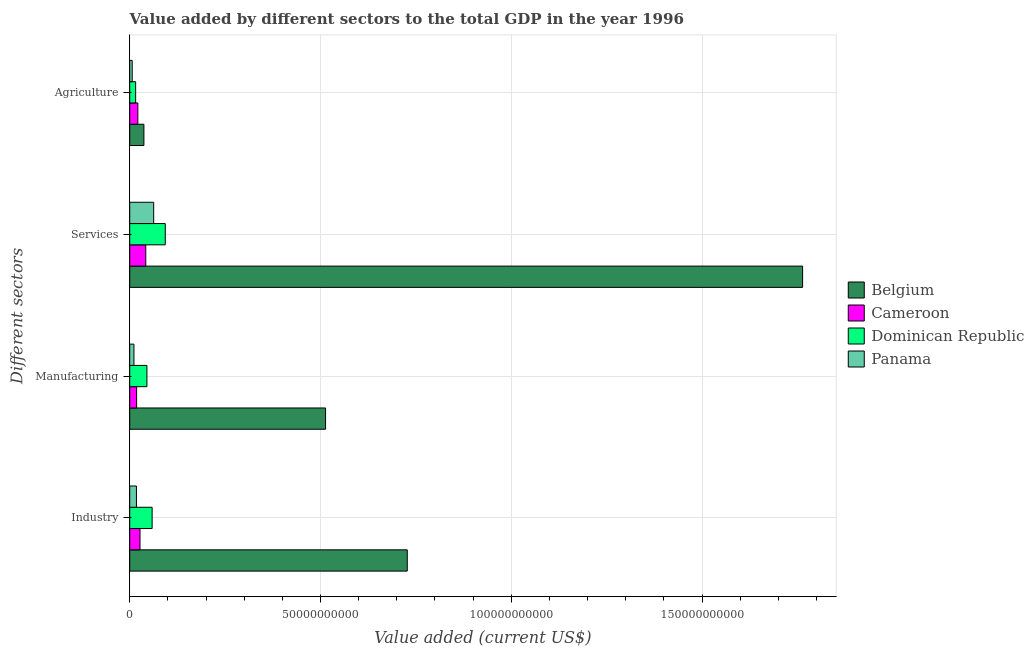How many different coloured bars are there?
Your response must be concise. 4. Are the number of bars on each tick of the Y-axis equal?
Offer a very short reply. Yes. How many bars are there on the 2nd tick from the bottom?
Offer a terse response. 4. What is the label of the 4th group of bars from the top?
Give a very brief answer. Industry. What is the value added by industrial sector in Cameroon?
Your answer should be compact. 2.69e+09. Across all countries, what is the maximum value added by manufacturing sector?
Your answer should be compact. 5.13e+1. Across all countries, what is the minimum value added by industrial sector?
Provide a short and direct response. 1.76e+09. In which country was the value added by industrial sector maximum?
Provide a succinct answer. Belgium. In which country was the value added by agricultural sector minimum?
Your answer should be very brief. Panama. What is the total value added by industrial sector in the graph?
Provide a short and direct response. 8.31e+1. What is the difference between the value added by manufacturing sector in Cameroon and that in Belgium?
Make the answer very short. -4.95e+1. What is the difference between the value added by industrial sector in Dominican Republic and the value added by manufacturing sector in Belgium?
Keep it short and to the point. -4.55e+1. What is the average value added by agricultural sector per country?
Make the answer very short. 2.01e+09. What is the difference between the value added by agricultural sector and value added by manufacturing sector in Cameroon?
Provide a succinct answer. 3.18e+08. In how many countries, is the value added by agricultural sector greater than 100000000000 US$?
Offer a very short reply. 0. What is the ratio of the value added by services sector in Dominican Republic to that in Panama?
Your answer should be very brief. 1.48. Is the difference between the value added by industrial sector in Belgium and Cameroon greater than the difference between the value added by services sector in Belgium and Cameroon?
Ensure brevity in your answer.  No. What is the difference between the highest and the second highest value added by agricultural sector?
Your response must be concise. 1.59e+09. What is the difference between the highest and the lowest value added by agricultural sector?
Your response must be concise. 3.07e+09. Is it the case that in every country, the sum of the value added by industrial sector and value added by agricultural sector is greater than the sum of value added by manufacturing sector and value added by services sector?
Offer a very short reply. No. What does the 1st bar from the top in Agriculture represents?
Your answer should be very brief. Panama. What does the 4th bar from the bottom in Manufacturing represents?
Keep it short and to the point. Panama. Is it the case that in every country, the sum of the value added by industrial sector and value added by manufacturing sector is greater than the value added by services sector?
Keep it short and to the point. No. Does the graph contain any zero values?
Your answer should be compact. No. Does the graph contain grids?
Your response must be concise. Yes. Where does the legend appear in the graph?
Provide a short and direct response. Center right. How many legend labels are there?
Offer a very short reply. 4. How are the legend labels stacked?
Keep it short and to the point. Vertical. What is the title of the graph?
Keep it short and to the point. Value added by different sectors to the total GDP in the year 1996. Does "Lebanon" appear as one of the legend labels in the graph?
Ensure brevity in your answer.  No. What is the label or title of the X-axis?
Your response must be concise. Value added (current US$). What is the label or title of the Y-axis?
Ensure brevity in your answer.  Different sectors. What is the Value added (current US$) of Belgium in Industry?
Offer a very short reply. 7.27e+1. What is the Value added (current US$) of Cameroon in Industry?
Keep it short and to the point. 2.69e+09. What is the Value added (current US$) of Dominican Republic in Industry?
Ensure brevity in your answer.  5.87e+09. What is the Value added (current US$) of Panama in Industry?
Your answer should be compact. 1.76e+09. What is the Value added (current US$) of Belgium in Manufacturing?
Provide a short and direct response. 5.13e+1. What is the Value added (current US$) of Cameroon in Manufacturing?
Make the answer very short. 1.81e+09. What is the Value added (current US$) in Dominican Republic in Manufacturing?
Give a very brief answer. 4.51e+09. What is the Value added (current US$) of Panama in Manufacturing?
Ensure brevity in your answer.  1.11e+09. What is the Value added (current US$) in Belgium in Services?
Provide a short and direct response. 1.76e+11. What is the Value added (current US$) in Cameroon in Services?
Your answer should be very brief. 4.20e+09. What is the Value added (current US$) in Dominican Republic in Services?
Your response must be concise. 9.31e+09. What is the Value added (current US$) in Panama in Services?
Provide a short and direct response. 6.28e+09. What is the Value added (current US$) of Belgium in Agriculture?
Provide a short and direct response. 3.72e+09. What is the Value added (current US$) of Cameroon in Agriculture?
Give a very brief answer. 2.13e+09. What is the Value added (current US$) of Dominican Republic in Agriculture?
Make the answer very short. 1.55e+09. What is the Value added (current US$) of Panama in Agriculture?
Your response must be concise. 6.49e+08. Across all Different sectors, what is the maximum Value added (current US$) of Belgium?
Make the answer very short. 1.76e+11. Across all Different sectors, what is the maximum Value added (current US$) of Cameroon?
Keep it short and to the point. 4.20e+09. Across all Different sectors, what is the maximum Value added (current US$) of Dominican Republic?
Your answer should be compact. 9.31e+09. Across all Different sectors, what is the maximum Value added (current US$) of Panama?
Your answer should be very brief. 6.28e+09. Across all Different sectors, what is the minimum Value added (current US$) in Belgium?
Provide a succinct answer. 3.72e+09. Across all Different sectors, what is the minimum Value added (current US$) of Cameroon?
Provide a short and direct response. 1.81e+09. Across all Different sectors, what is the minimum Value added (current US$) of Dominican Republic?
Ensure brevity in your answer.  1.55e+09. Across all Different sectors, what is the minimum Value added (current US$) in Panama?
Keep it short and to the point. 6.49e+08. What is the total Value added (current US$) of Belgium in the graph?
Your response must be concise. 3.04e+11. What is the total Value added (current US$) of Cameroon in the graph?
Make the answer very short. 1.08e+1. What is the total Value added (current US$) of Dominican Republic in the graph?
Make the answer very short. 2.12e+1. What is the total Value added (current US$) in Panama in the graph?
Your response must be concise. 9.79e+09. What is the difference between the Value added (current US$) in Belgium in Industry and that in Manufacturing?
Your answer should be compact. 2.14e+1. What is the difference between the Value added (current US$) of Cameroon in Industry and that in Manufacturing?
Give a very brief answer. 8.81e+08. What is the difference between the Value added (current US$) of Dominican Republic in Industry and that in Manufacturing?
Ensure brevity in your answer.  1.37e+09. What is the difference between the Value added (current US$) of Panama in Industry and that in Manufacturing?
Keep it short and to the point. 6.53e+08. What is the difference between the Value added (current US$) of Belgium in Industry and that in Services?
Provide a short and direct response. -1.04e+11. What is the difference between the Value added (current US$) of Cameroon in Industry and that in Services?
Your answer should be very brief. -1.51e+09. What is the difference between the Value added (current US$) in Dominican Republic in Industry and that in Services?
Provide a succinct answer. -3.44e+09. What is the difference between the Value added (current US$) of Panama in Industry and that in Services?
Offer a terse response. -4.52e+09. What is the difference between the Value added (current US$) of Belgium in Industry and that in Agriculture?
Keep it short and to the point. 6.90e+1. What is the difference between the Value added (current US$) of Cameroon in Industry and that in Agriculture?
Offer a terse response. 5.63e+08. What is the difference between the Value added (current US$) in Dominican Republic in Industry and that in Agriculture?
Keep it short and to the point. 4.32e+09. What is the difference between the Value added (current US$) of Panama in Industry and that in Agriculture?
Keep it short and to the point. 1.11e+09. What is the difference between the Value added (current US$) in Belgium in Manufacturing and that in Services?
Provide a succinct answer. -1.25e+11. What is the difference between the Value added (current US$) in Cameroon in Manufacturing and that in Services?
Your response must be concise. -2.39e+09. What is the difference between the Value added (current US$) of Dominican Republic in Manufacturing and that in Services?
Ensure brevity in your answer.  -4.81e+09. What is the difference between the Value added (current US$) of Panama in Manufacturing and that in Services?
Your answer should be compact. -5.17e+09. What is the difference between the Value added (current US$) of Belgium in Manufacturing and that in Agriculture?
Your response must be concise. 4.76e+1. What is the difference between the Value added (current US$) of Cameroon in Manufacturing and that in Agriculture?
Ensure brevity in your answer.  -3.18e+08. What is the difference between the Value added (current US$) in Dominican Republic in Manufacturing and that in Agriculture?
Provide a succinct answer. 2.96e+09. What is the difference between the Value added (current US$) of Panama in Manufacturing and that in Agriculture?
Give a very brief answer. 4.57e+08. What is the difference between the Value added (current US$) of Belgium in Services and that in Agriculture?
Offer a terse response. 1.73e+11. What is the difference between the Value added (current US$) in Cameroon in Services and that in Agriculture?
Ensure brevity in your answer.  2.08e+09. What is the difference between the Value added (current US$) in Dominican Republic in Services and that in Agriculture?
Your answer should be very brief. 7.76e+09. What is the difference between the Value added (current US$) in Panama in Services and that in Agriculture?
Offer a terse response. 5.63e+09. What is the difference between the Value added (current US$) in Belgium in Industry and the Value added (current US$) in Cameroon in Manufacturing?
Provide a succinct answer. 7.09e+1. What is the difference between the Value added (current US$) in Belgium in Industry and the Value added (current US$) in Dominican Republic in Manufacturing?
Offer a terse response. 6.82e+1. What is the difference between the Value added (current US$) in Belgium in Industry and the Value added (current US$) in Panama in Manufacturing?
Offer a very short reply. 7.16e+1. What is the difference between the Value added (current US$) in Cameroon in Industry and the Value added (current US$) in Dominican Republic in Manufacturing?
Make the answer very short. -1.82e+09. What is the difference between the Value added (current US$) of Cameroon in Industry and the Value added (current US$) of Panama in Manufacturing?
Give a very brief answer. 1.59e+09. What is the difference between the Value added (current US$) of Dominican Republic in Industry and the Value added (current US$) of Panama in Manufacturing?
Offer a terse response. 4.77e+09. What is the difference between the Value added (current US$) of Belgium in Industry and the Value added (current US$) of Cameroon in Services?
Offer a terse response. 6.85e+1. What is the difference between the Value added (current US$) of Belgium in Industry and the Value added (current US$) of Dominican Republic in Services?
Give a very brief answer. 6.34e+1. What is the difference between the Value added (current US$) in Belgium in Industry and the Value added (current US$) in Panama in Services?
Your response must be concise. 6.65e+1. What is the difference between the Value added (current US$) of Cameroon in Industry and the Value added (current US$) of Dominican Republic in Services?
Your response must be concise. -6.62e+09. What is the difference between the Value added (current US$) of Cameroon in Industry and the Value added (current US$) of Panama in Services?
Your answer should be very brief. -3.59e+09. What is the difference between the Value added (current US$) of Dominican Republic in Industry and the Value added (current US$) of Panama in Services?
Make the answer very short. -4.07e+08. What is the difference between the Value added (current US$) in Belgium in Industry and the Value added (current US$) in Cameroon in Agriculture?
Offer a very short reply. 7.06e+1. What is the difference between the Value added (current US$) in Belgium in Industry and the Value added (current US$) in Dominican Republic in Agriculture?
Offer a very short reply. 7.12e+1. What is the difference between the Value added (current US$) of Belgium in Industry and the Value added (current US$) of Panama in Agriculture?
Give a very brief answer. 7.21e+1. What is the difference between the Value added (current US$) of Cameroon in Industry and the Value added (current US$) of Dominican Republic in Agriculture?
Provide a short and direct response. 1.14e+09. What is the difference between the Value added (current US$) in Cameroon in Industry and the Value added (current US$) in Panama in Agriculture?
Keep it short and to the point. 2.04e+09. What is the difference between the Value added (current US$) of Dominican Republic in Industry and the Value added (current US$) of Panama in Agriculture?
Give a very brief answer. 5.22e+09. What is the difference between the Value added (current US$) in Belgium in Manufacturing and the Value added (current US$) in Cameroon in Services?
Provide a succinct answer. 4.71e+1. What is the difference between the Value added (current US$) of Belgium in Manufacturing and the Value added (current US$) of Dominican Republic in Services?
Your answer should be very brief. 4.20e+1. What is the difference between the Value added (current US$) of Belgium in Manufacturing and the Value added (current US$) of Panama in Services?
Your answer should be very brief. 4.51e+1. What is the difference between the Value added (current US$) in Cameroon in Manufacturing and the Value added (current US$) in Dominican Republic in Services?
Provide a short and direct response. -7.50e+09. What is the difference between the Value added (current US$) in Cameroon in Manufacturing and the Value added (current US$) in Panama in Services?
Your response must be concise. -4.47e+09. What is the difference between the Value added (current US$) of Dominican Republic in Manufacturing and the Value added (current US$) of Panama in Services?
Provide a succinct answer. -1.77e+09. What is the difference between the Value added (current US$) in Belgium in Manufacturing and the Value added (current US$) in Cameroon in Agriculture?
Offer a terse response. 4.92e+1. What is the difference between the Value added (current US$) of Belgium in Manufacturing and the Value added (current US$) of Dominican Republic in Agriculture?
Offer a terse response. 4.98e+1. What is the difference between the Value added (current US$) in Belgium in Manufacturing and the Value added (current US$) in Panama in Agriculture?
Keep it short and to the point. 5.07e+1. What is the difference between the Value added (current US$) of Cameroon in Manufacturing and the Value added (current US$) of Dominican Republic in Agriculture?
Give a very brief answer. 2.58e+08. What is the difference between the Value added (current US$) in Cameroon in Manufacturing and the Value added (current US$) in Panama in Agriculture?
Offer a terse response. 1.16e+09. What is the difference between the Value added (current US$) in Dominican Republic in Manufacturing and the Value added (current US$) in Panama in Agriculture?
Offer a terse response. 3.86e+09. What is the difference between the Value added (current US$) of Belgium in Services and the Value added (current US$) of Cameroon in Agriculture?
Your answer should be compact. 1.74e+11. What is the difference between the Value added (current US$) of Belgium in Services and the Value added (current US$) of Dominican Republic in Agriculture?
Provide a succinct answer. 1.75e+11. What is the difference between the Value added (current US$) of Belgium in Services and the Value added (current US$) of Panama in Agriculture?
Offer a terse response. 1.76e+11. What is the difference between the Value added (current US$) in Cameroon in Services and the Value added (current US$) in Dominican Republic in Agriculture?
Your answer should be very brief. 2.65e+09. What is the difference between the Value added (current US$) in Cameroon in Services and the Value added (current US$) in Panama in Agriculture?
Provide a short and direct response. 3.55e+09. What is the difference between the Value added (current US$) in Dominican Republic in Services and the Value added (current US$) in Panama in Agriculture?
Your response must be concise. 8.66e+09. What is the average Value added (current US$) of Belgium per Different sectors?
Your answer should be compact. 7.60e+1. What is the average Value added (current US$) of Cameroon per Different sectors?
Your response must be concise. 2.71e+09. What is the average Value added (current US$) of Dominican Republic per Different sectors?
Provide a short and direct response. 5.31e+09. What is the average Value added (current US$) of Panama per Different sectors?
Provide a short and direct response. 2.45e+09. What is the difference between the Value added (current US$) of Belgium and Value added (current US$) of Cameroon in Industry?
Your answer should be very brief. 7.01e+1. What is the difference between the Value added (current US$) in Belgium and Value added (current US$) in Dominican Republic in Industry?
Ensure brevity in your answer.  6.69e+1. What is the difference between the Value added (current US$) of Belgium and Value added (current US$) of Panama in Industry?
Ensure brevity in your answer.  7.10e+1. What is the difference between the Value added (current US$) of Cameroon and Value added (current US$) of Dominican Republic in Industry?
Offer a very short reply. -3.18e+09. What is the difference between the Value added (current US$) of Cameroon and Value added (current US$) of Panama in Industry?
Your response must be concise. 9.32e+08. What is the difference between the Value added (current US$) in Dominican Republic and Value added (current US$) in Panama in Industry?
Make the answer very short. 4.11e+09. What is the difference between the Value added (current US$) of Belgium and Value added (current US$) of Cameroon in Manufacturing?
Your answer should be compact. 4.95e+1. What is the difference between the Value added (current US$) of Belgium and Value added (current US$) of Dominican Republic in Manufacturing?
Your response must be concise. 4.68e+1. What is the difference between the Value added (current US$) of Belgium and Value added (current US$) of Panama in Manufacturing?
Your answer should be compact. 5.02e+1. What is the difference between the Value added (current US$) of Cameroon and Value added (current US$) of Dominican Republic in Manufacturing?
Provide a short and direct response. -2.70e+09. What is the difference between the Value added (current US$) of Cameroon and Value added (current US$) of Panama in Manufacturing?
Your response must be concise. 7.05e+08. What is the difference between the Value added (current US$) of Dominican Republic and Value added (current US$) of Panama in Manufacturing?
Make the answer very short. 3.40e+09. What is the difference between the Value added (current US$) in Belgium and Value added (current US$) in Cameroon in Services?
Provide a short and direct response. 1.72e+11. What is the difference between the Value added (current US$) in Belgium and Value added (current US$) in Dominican Republic in Services?
Your response must be concise. 1.67e+11. What is the difference between the Value added (current US$) in Belgium and Value added (current US$) in Panama in Services?
Ensure brevity in your answer.  1.70e+11. What is the difference between the Value added (current US$) in Cameroon and Value added (current US$) in Dominican Republic in Services?
Your answer should be very brief. -5.11e+09. What is the difference between the Value added (current US$) in Cameroon and Value added (current US$) in Panama in Services?
Make the answer very short. -2.08e+09. What is the difference between the Value added (current US$) in Dominican Republic and Value added (current US$) in Panama in Services?
Offer a very short reply. 3.03e+09. What is the difference between the Value added (current US$) of Belgium and Value added (current US$) of Cameroon in Agriculture?
Your answer should be compact. 1.59e+09. What is the difference between the Value added (current US$) in Belgium and Value added (current US$) in Dominican Republic in Agriculture?
Your answer should be very brief. 2.17e+09. What is the difference between the Value added (current US$) in Belgium and Value added (current US$) in Panama in Agriculture?
Your answer should be compact. 3.07e+09. What is the difference between the Value added (current US$) of Cameroon and Value added (current US$) of Dominican Republic in Agriculture?
Your response must be concise. 5.77e+08. What is the difference between the Value added (current US$) in Cameroon and Value added (current US$) in Panama in Agriculture?
Give a very brief answer. 1.48e+09. What is the difference between the Value added (current US$) of Dominican Republic and Value added (current US$) of Panama in Agriculture?
Your answer should be very brief. 9.03e+08. What is the ratio of the Value added (current US$) of Belgium in Industry to that in Manufacturing?
Provide a succinct answer. 1.42. What is the ratio of the Value added (current US$) of Cameroon in Industry to that in Manufacturing?
Keep it short and to the point. 1.49. What is the ratio of the Value added (current US$) in Dominican Republic in Industry to that in Manufacturing?
Give a very brief answer. 1.3. What is the ratio of the Value added (current US$) in Panama in Industry to that in Manufacturing?
Keep it short and to the point. 1.59. What is the ratio of the Value added (current US$) of Belgium in Industry to that in Services?
Your response must be concise. 0.41. What is the ratio of the Value added (current US$) of Cameroon in Industry to that in Services?
Your answer should be very brief. 0.64. What is the ratio of the Value added (current US$) of Dominican Republic in Industry to that in Services?
Give a very brief answer. 0.63. What is the ratio of the Value added (current US$) of Panama in Industry to that in Services?
Give a very brief answer. 0.28. What is the ratio of the Value added (current US$) of Belgium in Industry to that in Agriculture?
Your answer should be very brief. 19.57. What is the ratio of the Value added (current US$) in Cameroon in Industry to that in Agriculture?
Provide a succinct answer. 1.26. What is the ratio of the Value added (current US$) in Dominican Republic in Industry to that in Agriculture?
Your answer should be compact. 3.78. What is the ratio of the Value added (current US$) in Panama in Industry to that in Agriculture?
Your response must be concise. 2.71. What is the ratio of the Value added (current US$) of Belgium in Manufacturing to that in Services?
Give a very brief answer. 0.29. What is the ratio of the Value added (current US$) of Cameroon in Manufacturing to that in Services?
Offer a terse response. 0.43. What is the ratio of the Value added (current US$) in Dominican Republic in Manufacturing to that in Services?
Your answer should be very brief. 0.48. What is the ratio of the Value added (current US$) of Panama in Manufacturing to that in Services?
Provide a short and direct response. 0.18. What is the ratio of the Value added (current US$) in Belgium in Manufacturing to that in Agriculture?
Provide a short and direct response. 13.81. What is the ratio of the Value added (current US$) of Cameroon in Manufacturing to that in Agriculture?
Provide a succinct answer. 0.85. What is the ratio of the Value added (current US$) of Dominican Republic in Manufacturing to that in Agriculture?
Keep it short and to the point. 2.9. What is the ratio of the Value added (current US$) of Panama in Manufacturing to that in Agriculture?
Give a very brief answer. 1.7. What is the ratio of the Value added (current US$) in Belgium in Services to that in Agriculture?
Your response must be concise. 47.45. What is the ratio of the Value added (current US$) of Cameroon in Services to that in Agriculture?
Give a very brief answer. 1.98. What is the ratio of the Value added (current US$) of Dominican Republic in Services to that in Agriculture?
Your answer should be compact. 6. What is the ratio of the Value added (current US$) of Panama in Services to that in Agriculture?
Your response must be concise. 9.67. What is the difference between the highest and the second highest Value added (current US$) in Belgium?
Your answer should be very brief. 1.04e+11. What is the difference between the highest and the second highest Value added (current US$) in Cameroon?
Offer a terse response. 1.51e+09. What is the difference between the highest and the second highest Value added (current US$) of Dominican Republic?
Make the answer very short. 3.44e+09. What is the difference between the highest and the second highest Value added (current US$) in Panama?
Ensure brevity in your answer.  4.52e+09. What is the difference between the highest and the lowest Value added (current US$) in Belgium?
Provide a short and direct response. 1.73e+11. What is the difference between the highest and the lowest Value added (current US$) in Cameroon?
Keep it short and to the point. 2.39e+09. What is the difference between the highest and the lowest Value added (current US$) of Dominican Republic?
Provide a short and direct response. 7.76e+09. What is the difference between the highest and the lowest Value added (current US$) in Panama?
Your answer should be very brief. 5.63e+09. 